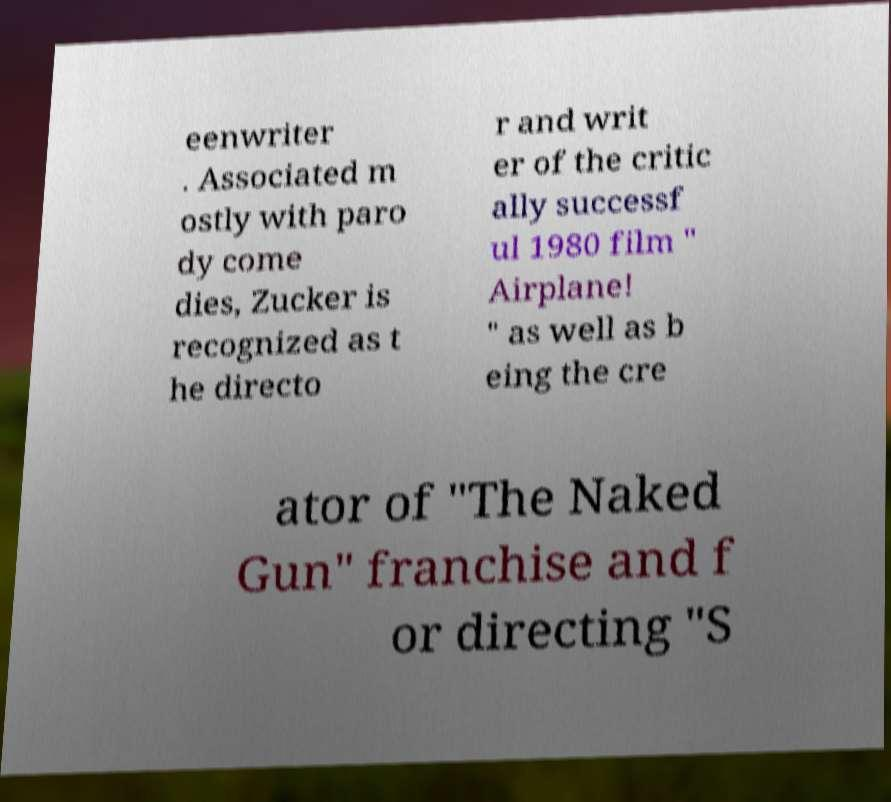Please identify and transcribe the text found in this image. eenwriter . Associated m ostly with paro dy come dies, Zucker is recognized as t he directo r and writ er of the critic ally successf ul 1980 film " Airplane! " as well as b eing the cre ator of "The Naked Gun" franchise and f or directing "S 